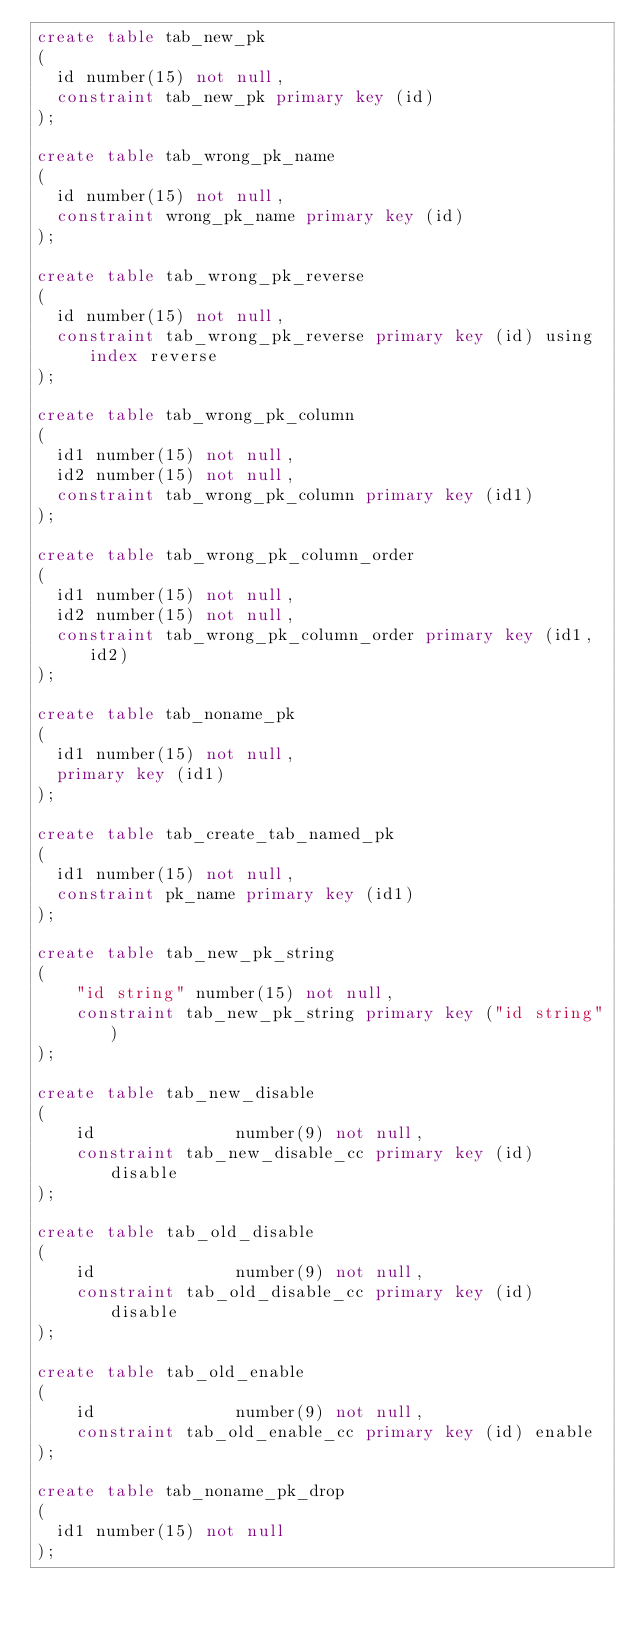<code> <loc_0><loc_0><loc_500><loc_500><_SQL_>create table tab_new_pk
(
  id number(15) not null,
  constraint tab_new_pk primary key (id)
);

create table tab_wrong_pk_name
(
  id number(15) not null,
  constraint wrong_pk_name primary key (id)
);

create table tab_wrong_pk_reverse
(
  id number(15) not null,
  constraint tab_wrong_pk_reverse primary key (id) using index reverse
);

create table tab_wrong_pk_column
(
  id1 number(15) not null,
  id2 number(15) not null,
  constraint tab_wrong_pk_column primary key (id1)
);

create table tab_wrong_pk_column_order
(
  id1 number(15) not null,
  id2 number(15) not null,
  constraint tab_wrong_pk_column_order primary key (id1,id2)
);

create table tab_noname_pk
(
  id1 number(15) not null,
  primary key (id1)
);

create table tab_create_tab_named_pk
(
  id1 number(15) not null,
  constraint pk_name primary key (id1)
);

create table tab_new_pk_string
(
    "id string" number(15) not null,
    constraint tab_new_pk_string primary key ("id string")
);

create table tab_new_disable
(
	id				number(9) not null,
	constraint tab_new_disable_cc primary key (id) disable
);

create table tab_old_disable
(
	id				number(9) not null,
	constraint tab_old_disable_cc primary key (id) disable
);

create table tab_old_enable
(
	id				number(9) not null,
	constraint tab_old_enable_cc primary key (id) enable
);

create table tab_noname_pk_drop
(
  id1 number(15) not null
);
</code> 